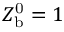<formula> <loc_0><loc_0><loc_500><loc_500>Z _ { b } ^ { 0 } = 1</formula> 